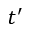Convert formula to latex. <formula><loc_0><loc_0><loc_500><loc_500>t ^ { \prime }</formula> 